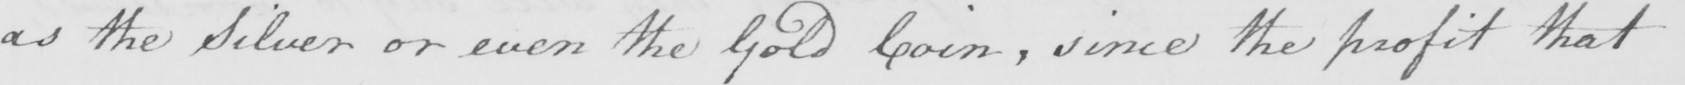Please provide the text content of this handwritten line. as the Silver or even the Gold Coin, since the profit that 